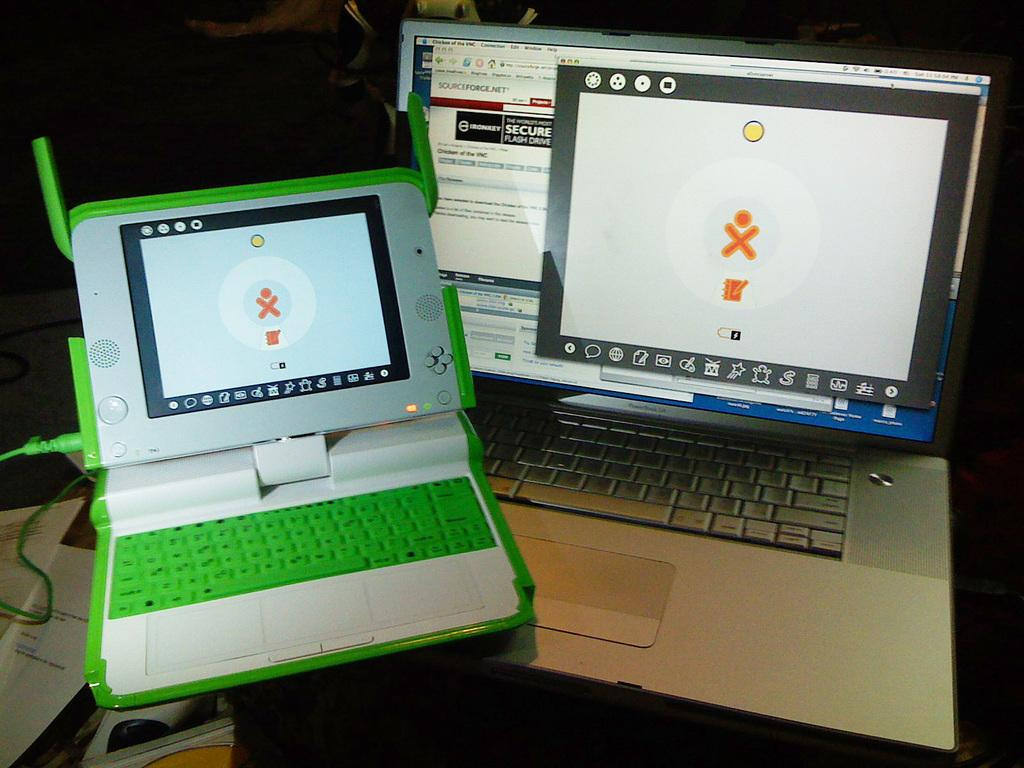<image>
Relay a brief, clear account of the picture shown. Two lap top screens with an orange x and a circle the one has an add on it that says secure flash drive. 